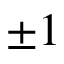Convert formula to latex. <formula><loc_0><loc_0><loc_500><loc_500>\pm 1</formula> 